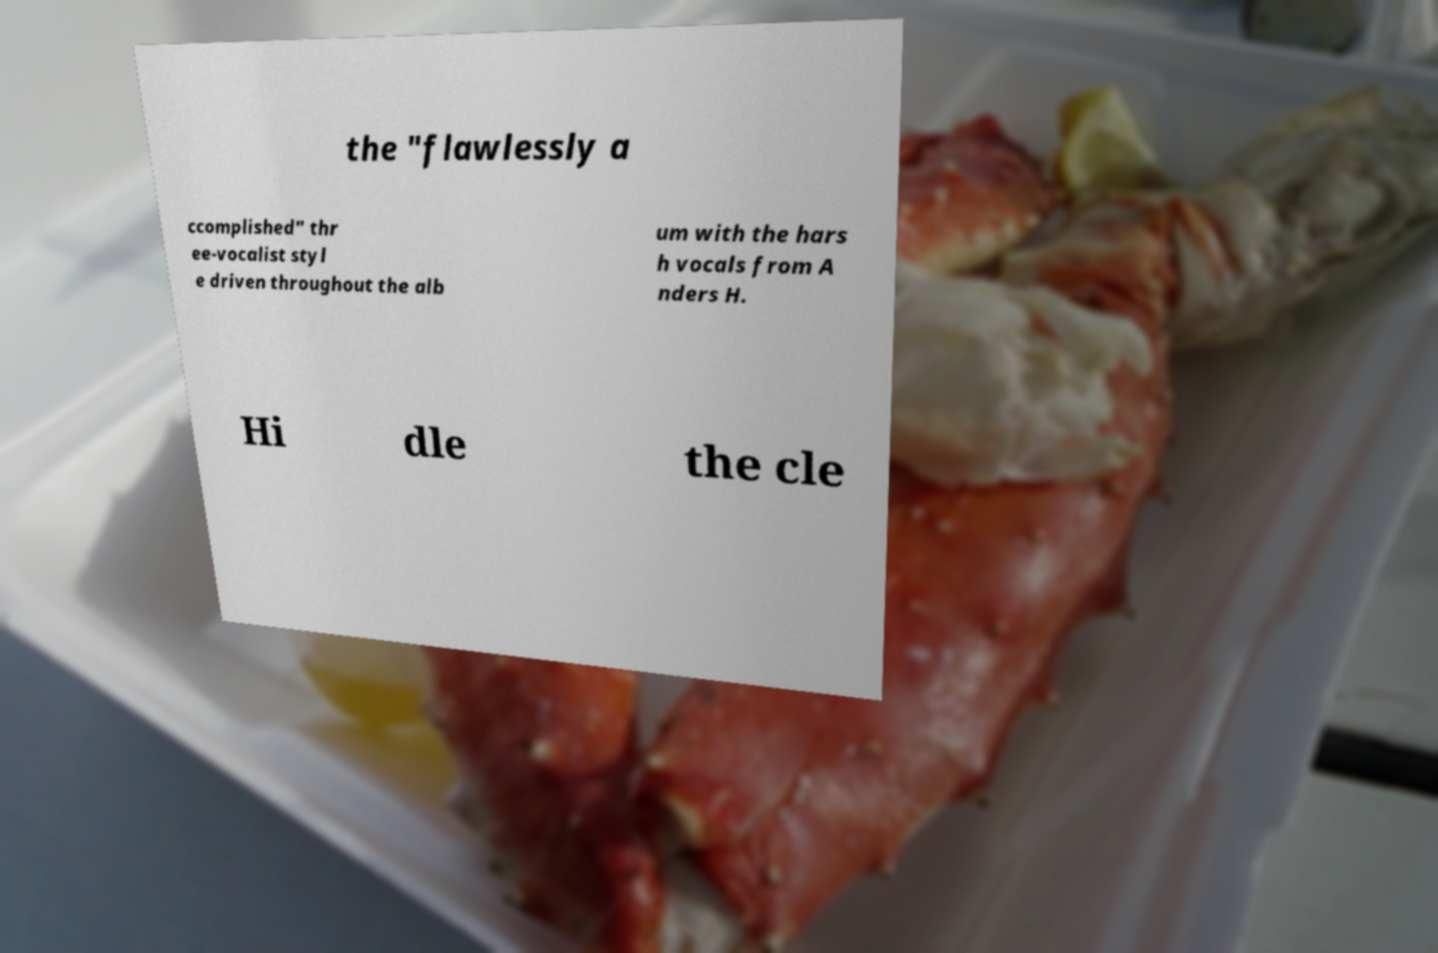For documentation purposes, I need the text within this image transcribed. Could you provide that? the "flawlessly a ccomplished" thr ee-vocalist styl e driven throughout the alb um with the hars h vocals from A nders H. Hi dle the cle 